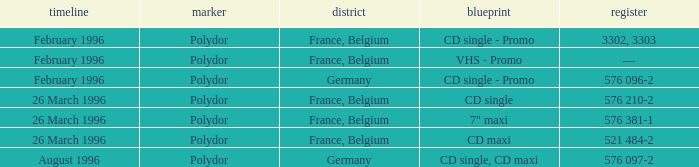Name the catalog for 26 march 1996 576 210-2, 576 381-1, 521 484-2. 